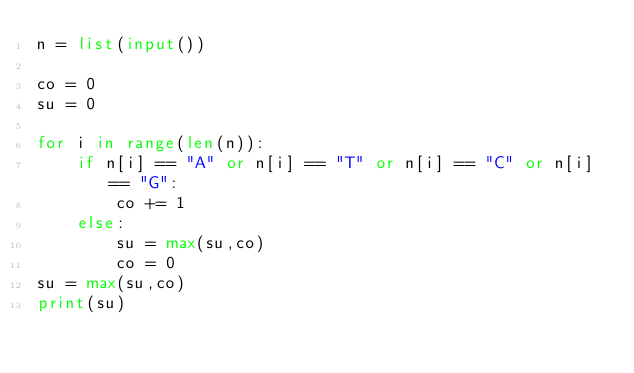Convert code to text. <code><loc_0><loc_0><loc_500><loc_500><_Python_>n = list(input())

co = 0
su = 0

for i in range(len(n)):
    if n[i] == "A" or n[i] == "T" or n[i] == "C" or n[i] == "G":
        co += 1
    else:
        su = max(su,co)
        co = 0
su = max(su,co)
print(su)</code> 